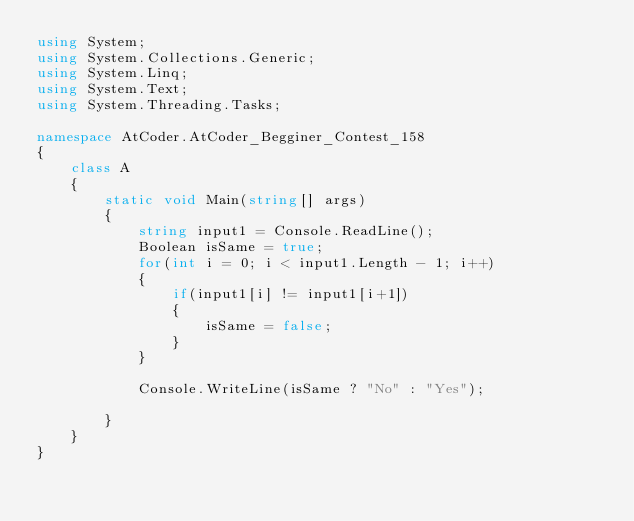<code> <loc_0><loc_0><loc_500><loc_500><_C#_>using System;
using System.Collections.Generic;
using System.Linq;
using System.Text;
using System.Threading.Tasks;

namespace AtCoder.AtCoder_Begginer_Contest_158
{
    class A
    {
        static void Main(string[] args)
        {
            string input1 = Console.ReadLine();
            Boolean isSame = true;
            for(int i = 0; i < input1.Length - 1; i++)
            {
                if(input1[i] != input1[i+1])
                {
                    isSame = false;
                }
            }

            Console.WriteLine(isSame ? "No" : "Yes");

        }
    }
}
</code> 